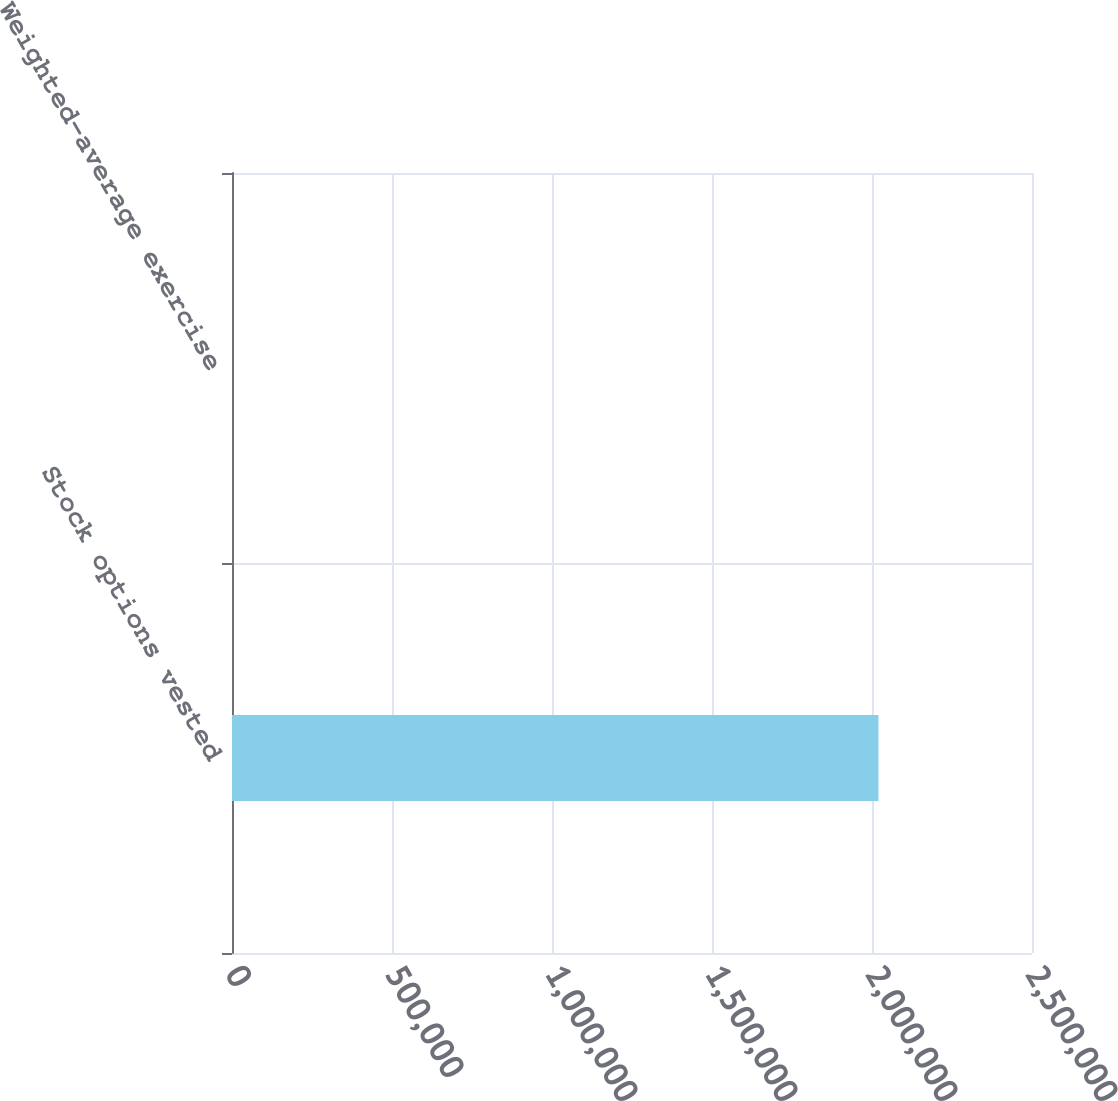Convert chart. <chart><loc_0><loc_0><loc_500><loc_500><bar_chart><fcel>Stock options vested<fcel>Weighted-average exercise<nl><fcel>2.02005e+06<fcel>40.8<nl></chart> 